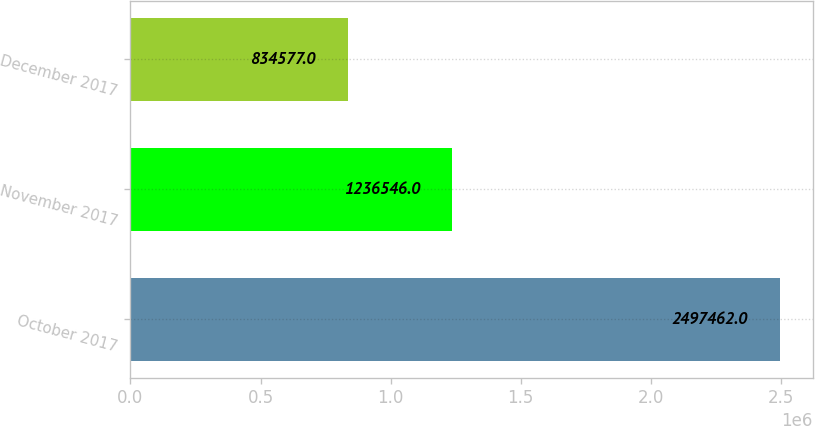Convert chart to OTSL. <chart><loc_0><loc_0><loc_500><loc_500><bar_chart><fcel>October 2017<fcel>November 2017<fcel>December 2017<nl><fcel>2.49746e+06<fcel>1.23655e+06<fcel>834577<nl></chart> 